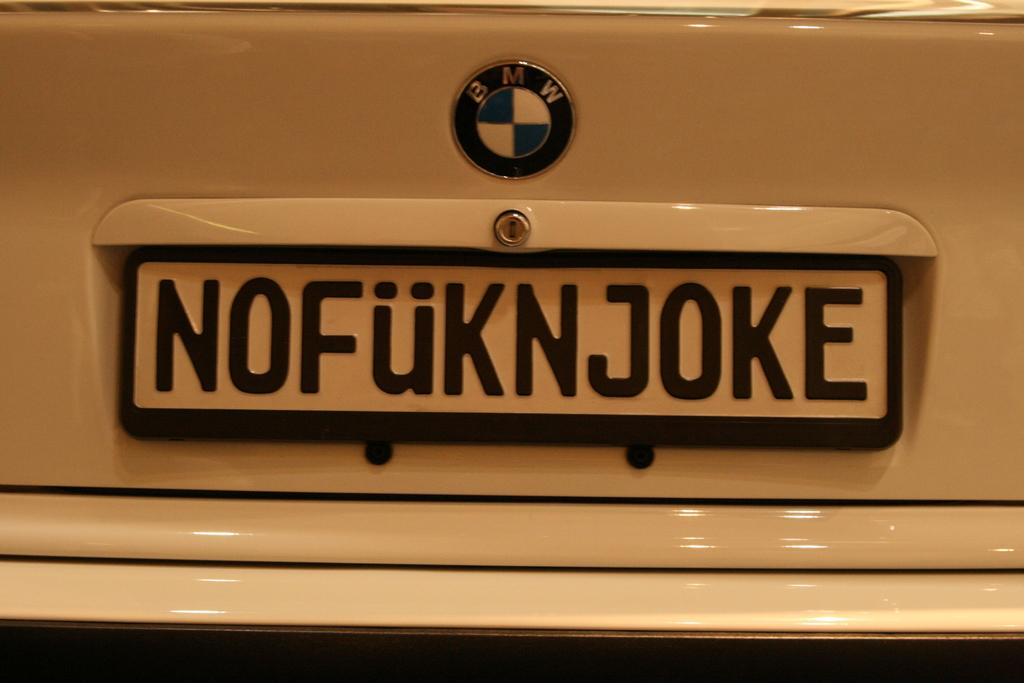<image>
Give a short and clear explanation of the subsequent image. a tag on a BMW that reads NOFuKNJOKE 